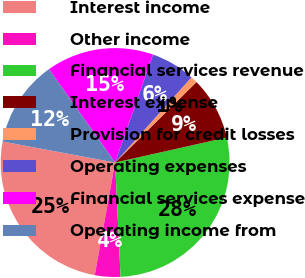Convert chart. <chart><loc_0><loc_0><loc_500><loc_500><pie_chart><fcel>Interest income<fcel>Other income<fcel>Financial services revenue<fcel>Interest expense<fcel>Provision for credit losses<fcel>Operating expenses<fcel>Financial services expense<fcel>Operating income from<nl><fcel>25.1%<fcel>3.6%<fcel>27.75%<fcel>8.9%<fcel>0.96%<fcel>6.25%<fcel>15.19%<fcel>12.24%<nl></chart> 